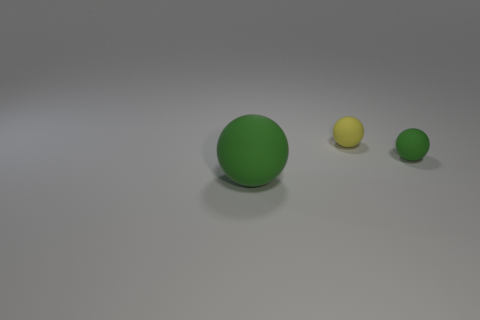Add 3 tiny green metallic spheres. How many objects exist? 6 Subtract 0 yellow cubes. How many objects are left? 3 Subtract all small blue metallic things. Subtract all yellow objects. How many objects are left? 2 Add 1 small yellow objects. How many small yellow objects are left? 2 Add 1 green matte balls. How many green matte balls exist? 3 